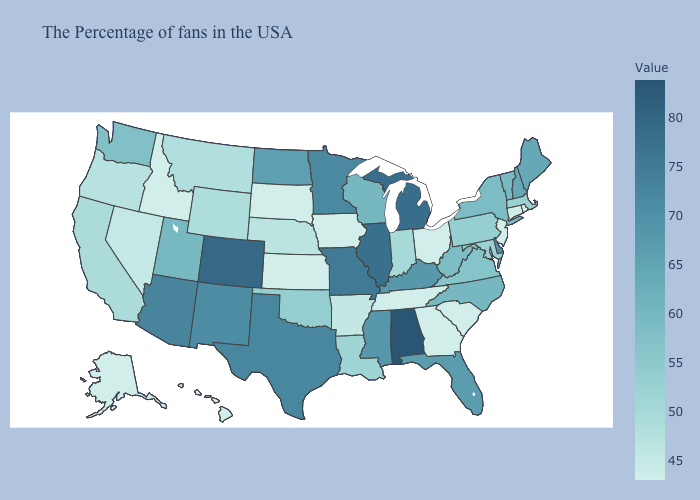Does Alabama have the highest value in the South?
Give a very brief answer. Yes. Does Rhode Island have the highest value in the USA?
Quick response, please. No. Does Alabama have the highest value in the USA?
Concise answer only. Yes. Does Michigan have the lowest value in the USA?
Answer briefly. No. Which states hav the highest value in the South?
Write a very short answer. Alabama. 